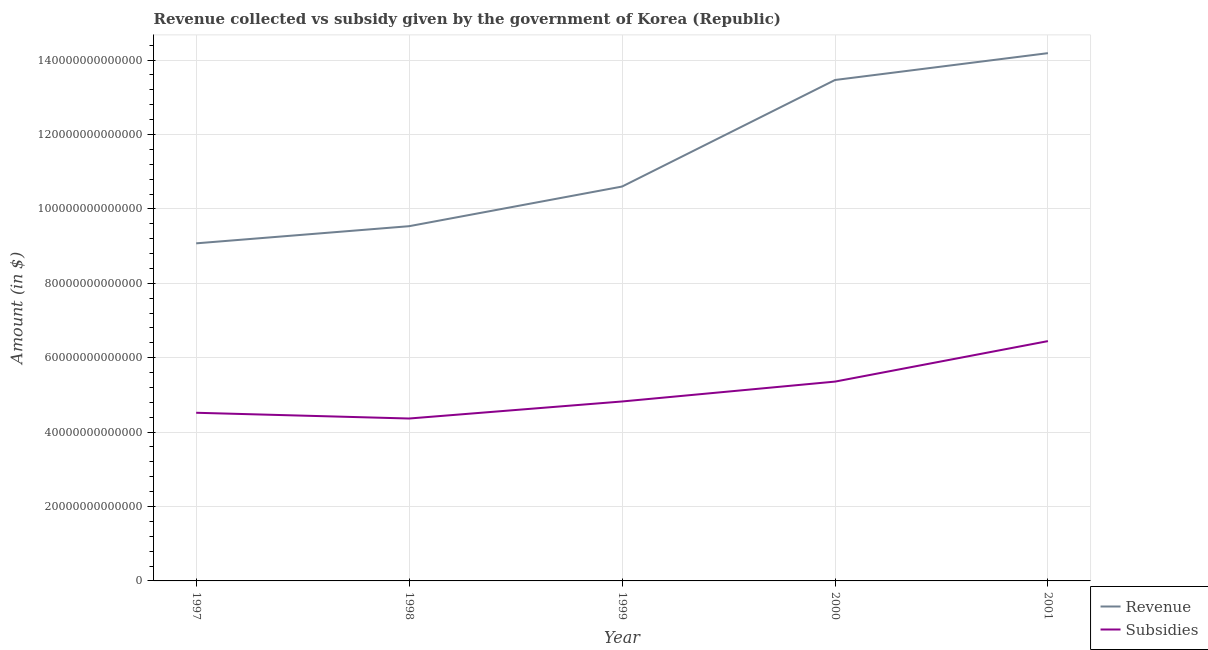How many different coloured lines are there?
Your response must be concise. 2. Is the number of lines equal to the number of legend labels?
Offer a very short reply. Yes. What is the amount of subsidies given in 1997?
Your answer should be compact. 4.52e+13. Across all years, what is the maximum amount of revenue collected?
Offer a very short reply. 1.42e+14. Across all years, what is the minimum amount of revenue collected?
Give a very brief answer. 9.07e+13. In which year was the amount of revenue collected maximum?
Your answer should be compact. 2001. What is the total amount of subsidies given in the graph?
Ensure brevity in your answer.  2.55e+14. What is the difference between the amount of revenue collected in 1997 and that in 1998?
Offer a terse response. -4.61e+12. What is the difference between the amount of revenue collected in 1997 and the amount of subsidies given in 1999?
Ensure brevity in your answer.  4.25e+13. What is the average amount of subsidies given per year?
Offer a terse response. 5.10e+13. In the year 2001, what is the difference between the amount of subsidies given and amount of revenue collected?
Make the answer very short. -7.74e+13. In how many years, is the amount of subsidies given greater than 124000000000000 $?
Keep it short and to the point. 0. What is the ratio of the amount of revenue collected in 1997 to that in 1998?
Ensure brevity in your answer.  0.95. Is the difference between the amount of revenue collected in 1997 and 2000 greater than the difference between the amount of subsidies given in 1997 and 2000?
Offer a very short reply. No. What is the difference between the highest and the second highest amount of subsidies given?
Make the answer very short. 1.09e+13. What is the difference between the highest and the lowest amount of revenue collected?
Make the answer very short. 5.11e+13. Is the sum of the amount of revenue collected in 2000 and 2001 greater than the maximum amount of subsidies given across all years?
Make the answer very short. Yes. What is the difference between two consecutive major ticks on the Y-axis?
Give a very brief answer. 2.00e+13. Are the values on the major ticks of Y-axis written in scientific E-notation?
Ensure brevity in your answer.  No. Does the graph contain any zero values?
Ensure brevity in your answer.  No. Does the graph contain grids?
Keep it short and to the point. Yes. Where does the legend appear in the graph?
Provide a short and direct response. Bottom right. How many legend labels are there?
Your answer should be compact. 2. What is the title of the graph?
Ensure brevity in your answer.  Revenue collected vs subsidy given by the government of Korea (Republic). What is the label or title of the Y-axis?
Keep it short and to the point. Amount (in $). What is the Amount (in $) of Revenue in 1997?
Your answer should be compact. 9.07e+13. What is the Amount (in $) in Subsidies in 1997?
Keep it short and to the point. 4.52e+13. What is the Amount (in $) of Revenue in 1998?
Your response must be concise. 9.53e+13. What is the Amount (in $) of Subsidies in 1998?
Ensure brevity in your answer.  4.37e+13. What is the Amount (in $) in Revenue in 1999?
Provide a succinct answer. 1.06e+14. What is the Amount (in $) in Subsidies in 1999?
Your answer should be compact. 4.82e+13. What is the Amount (in $) of Revenue in 2000?
Your response must be concise. 1.35e+14. What is the Amount (in $) in Subsidies in 2000?
Make the answer very short. 5.36e+13. What is the Amount (in $) in Revenue in 2001?
Provide a short and direct response. 1.42e+14. What is the Amount (in $) in Subsidies in 2001?
Your response must be concise. 6.45e+13. Across all years, what is the maximum Amount (in $) of Revenue?
Your response must be concise. 1.42e+14. Across all years, what is the maximum Amount (in $) of Subsidies?
Give a very brief answer. 6.45e+13. Across all years, what is the minimum Amount (in $) of Revenue?
Provide a short and direct response. 9.07e+13. Across all years, what is the minimum Amount (in $) in Subsidies?
Your answer should be compact. 4.37e+13. What is the total Amount (in $) of Revenue in the graph?
Provide a short and direct response. 5.69e+14. What is the total Amount (in $) of Subsidies in the graph?
Your answer should be compact. 2.55e+14. What is the difference between the Amount (in $) of Revenue in 1997 and that in 1998?
Make the answer very short. -4.61e+12. What is the difference between the Amount (in $) in Subsidies in 1997 and that in 1998?
Give a very brief answer. 1.55e+12. What is the difference between the Amount (in $) in Revenue in 1997 and that in 1999?
Keep it short and to the point. -1.53e+13. What is the difference between the Amount (in $) in Subsidies in 1997 and that in 1999?
Offer a very short reply. -3.03e+12. What is the difference between the Amount (in $) in Revenue in 1997 and that in 2000?
Your answer should be very brief. -4.39e+13. What is the difference between the Amount (in $) in Subsidies in 1997 and that in 2000?
Your answer should be compact. -8.38e+12. What is the difference between the Amount (in $) of Revenue in 1997 and that in 2001?
Keep it short and to the point. -5.11e+13. What is the difference between the Amount (in $) in Subsidies in 1997 and that in 2001?
Your answer should be compact. -1.93e+13. What is the difference between the Amount (in $) in Revenue in 1998 and that in 1999?
Provide a succinct answer. -1.07e+13. What is the difference between the Amount (in $) of Subsidies in 1998 and that in 1999?
Ensure brevity in your answer.  -4.58e+12. What is the difference between the Amount (in $) of Revenue in 1998 and that in 2000?
Your response must be concise. -3.93e+13. What is the difference between the Amount (in $) of Subsidies in 1998 and that in 2000?
Ensure brevity in your answer.  -9.92e+12. What is the difference between the Amount (in $) in Revenue in 1998 and that in 2001?
Offer a terse response. -4.65e+13. What is the difference between the Amount (in $) of Subsidies in 1998 and that in 2001?
Ensure brevity in your answer.  -2.08e+13. What is the difference between the Amount (in $) in Revenue in 1999 and that in 2000?
Your response must be concise. -2.86e+13. What is the difference between the Amount (in $) in Subsidies in 1999 and that in 2000?
Make the answer very short. -5.34e+12. What is the difference between the Amount (in $) of Revenue in 1999 and that in 2001?
Provide a short and direct response. -3.59e+13. What is the difference between the Amount (in $) of Subsidies in 1999 and that in 2001?
Offer a very short reply. -1.62e+13. What is the difference between the Amount (in $) in Revenue in 2000 and that in 2001?
Offer a very short reply. -7.22e+12. What is the difference between the Amount (in $) of Subsidies in 2000 and that in 2001?
Provide a short and direct response. -1.09e+13. What is the difference between the Amount (in $) of Revenue in 1997 and the Amount (in $) of Subsidies in 1998?
Offer a terse response. 4.71e+13. What is the difference between the Amount (in $) in Revenue in 1997 and the Amount (in $) in Subsidies in 1999?
Your answer should be compact. 4.25e+13. What is the difference between the Amount (in $) in Revenue in 1997 and the Amount (in $) in Subsidies in 2000?
Offer a very short reply. 3.72e+13. What is the difference between the Amount (in $) of Revenue in 1997 and the Amount (in $) of Subsidies in 2001?
Make the answer very short. 2.63e+13. What is the difference between the Amount (in $) in Revenue in 1998 and the Amount (in $) in Subsidies in 1999?
Ensure brevity in your answer.  4.71e+13. What is the difference between the Amount (in $) of Revenue in 1998 and the Amount (in $) of Subsidies in 2000?
Your answer should be very brief. 4.18e+13. What is the difference between the Amount (in $) in Revenue in 1998 and the Amount (in $) in Subsidies in 2001?
Offer a very short reply. 3.09e+13. What is the difference between the Amount (in $) in Revenue in 1999 and the Amount (in $) in Subsidies in 2000?
Offer a very short reply. 5.24e+13. What is the difference between the Amount (in $) in Revenue in 1999 and the Amount (in $) in Subsidies in 2001?
Provide a succinct answer. 4.15e+13. What is the difference between the Amount (in $) of Revenue in 2000 and the Amount (in $) of Subsidies in 2001?
Your answer should be very brief. 7.02e+13. What is the average Amount (in $) in Revenue per year?
Give a very brief answer. 1.14e+14. What is the average Amount (in $) in Subsidies per year?
Your response must be concise. 5.10e+13. In the year 1997, what is the difference between the Amount (in $) of Revenue and Amount (in $) of Subsidies?
Your response must be concise. 4.55e+13. In the year 1998, what is the difference between the Amount (in $) in Revenue and Amount (in $) in Subsidies?
Provide a succinct answer. 5.17e+13. In the year 1999, what is the difference between the Amount (in $) in Revenue and Amount (in $) in Subsidies?
Make the answer very short. 5.78e+13. In the year 2000, what is the difference between the Amount (in $) of Revenue and Amount (in $) of Subsidies?
Give a very brief answer. 8.11e+13. In the year 2001, what is the difference between the Amount (in $) of Revenue and Amount (in $) of Subsidies?
Your response must be concise. 7.74e+13. What is the ratio of the Amount (in $) of Revenue in 1997 to that in 1998?
Provide a short and direct response. 0.95. What is the ratio of the Amount (in $) in Subsidies in 1997 to that in 1998?
Your answer should be very brief. 1.04. What is the ratio of the Amount (in $) in Revenue in 1997 to that in 1999?
Offer a very short reply. 0.86. What is the ratio of the Amount (in $) in Subsidies in 1997 to that in 1999?
Offer a very short reply. 0.94. What is the ratio of the Amount (in $) of Revenue in 1997 to that in 2000?
Make the answer very short. 0.67. What is the ratio of the Amount (in $) of Subsidies in 1997 to that in 2000?
Provide a short and direct response. 0.84. What is the ratio of the Amount (in $) in Revenue in 1997 to that in 2001?
Your answer should be compact. 0.64. What is the ratio of the Amount (in $) in Subsidies in 1997 to that in 2001?
Make the answer very short. 0.7. What is the ratio of the Amount (in $) of Revenue in 1998 to that in 1999?
Give a very brief answer. 0.9. What is the ratio of the Amount (in $) in Subsidies in 1998 to that in 1999?
Give a very brief answer. 0.91. What is the ratio of the Amount (in $) in Revenue in 1998 to that in 2000?
Provide a short and direct response. 0.71. What is the ratio of the Amount (in $) of Subsidies in 1998 to that in 2000?
Your answer should be very brief. 0.81. What is the ratio of the Amount (in $) of Revenue in 1998 to that in 2001?
Provide a succinct answer. 0.67. What is the ratio of the Amount (in $) in Subsidies in 1998 to that in 2001?
Provide a short and direct response. 0.68. What is the ratio of the Amount (in $) of Revenue in 1999 to that in 2000?
Keep it short and to the point. 0.79. What is the ratio of the Amount (in $) in Subsidies in 1999 to that in 2000?
Your answer should be compact. 0.9. What is the ratio of the Amount (in $) in Revenue in 1999 to that in 2001?
Provide a succinct answer. 0.75. What is the ratio of the Amount (in $) of Subsidies in 1999 to that in 2001?
Provide a short and direct response. 0.75. What is the ratio of the Amount (in $) of Revenue in 2000 to that in 2001?
Give a very brief answer. 0.95. What is the ratio of the Amount (in $) in Subsidies in 2000 to that in 2001?
Offer a terse response. 0.83. What is the difference between the highest and the second highest Amount (in $) in Revenue?
Give a very brief answer. 7.22e+12. What is the difference between the highest and the second highest Amount (in $) in Subsidies?
Your response must be concise. 1.09e+13. What is the difference between the highest and the lowest Amount (in $) of Revenue?
Keep it short and to the point. 5.11e+13. What is the difference between the highest and the lowest Amount (in $) in Subsidies?
Keep it short and to the point. 2.08e+13. 